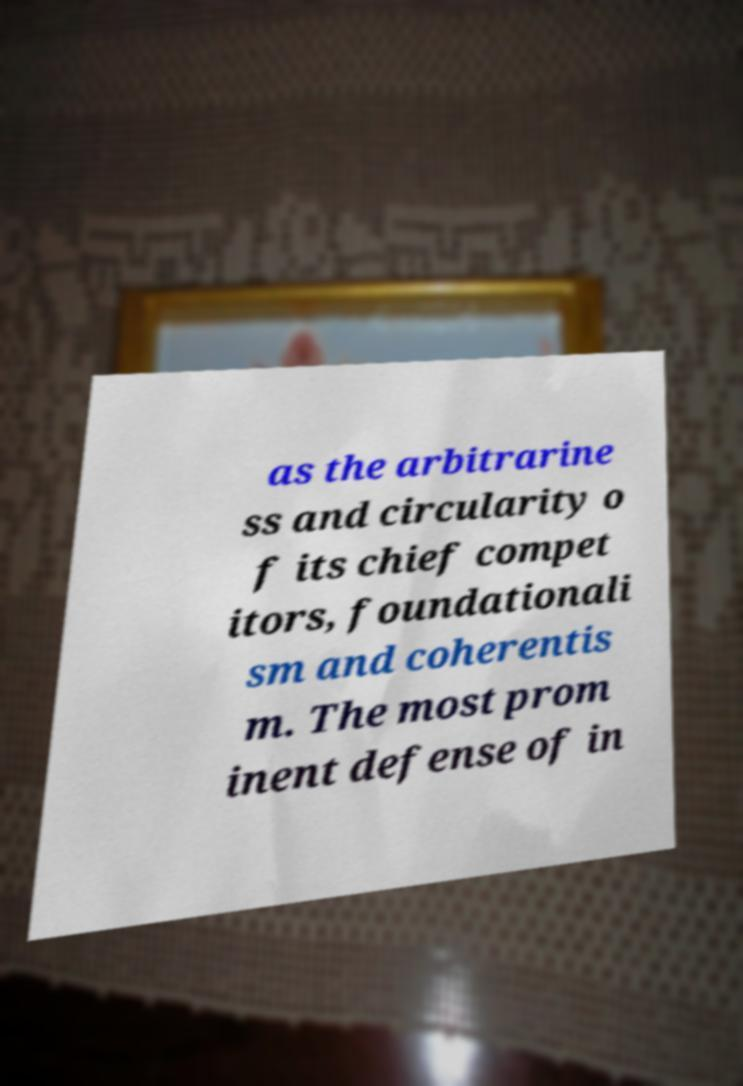Please read and relay the text visible in this image. What does it say? as the arbitrarine ss and circularity o f its chief compet itors, foundationali sm and coherentis m. The most prom inent defense of in 